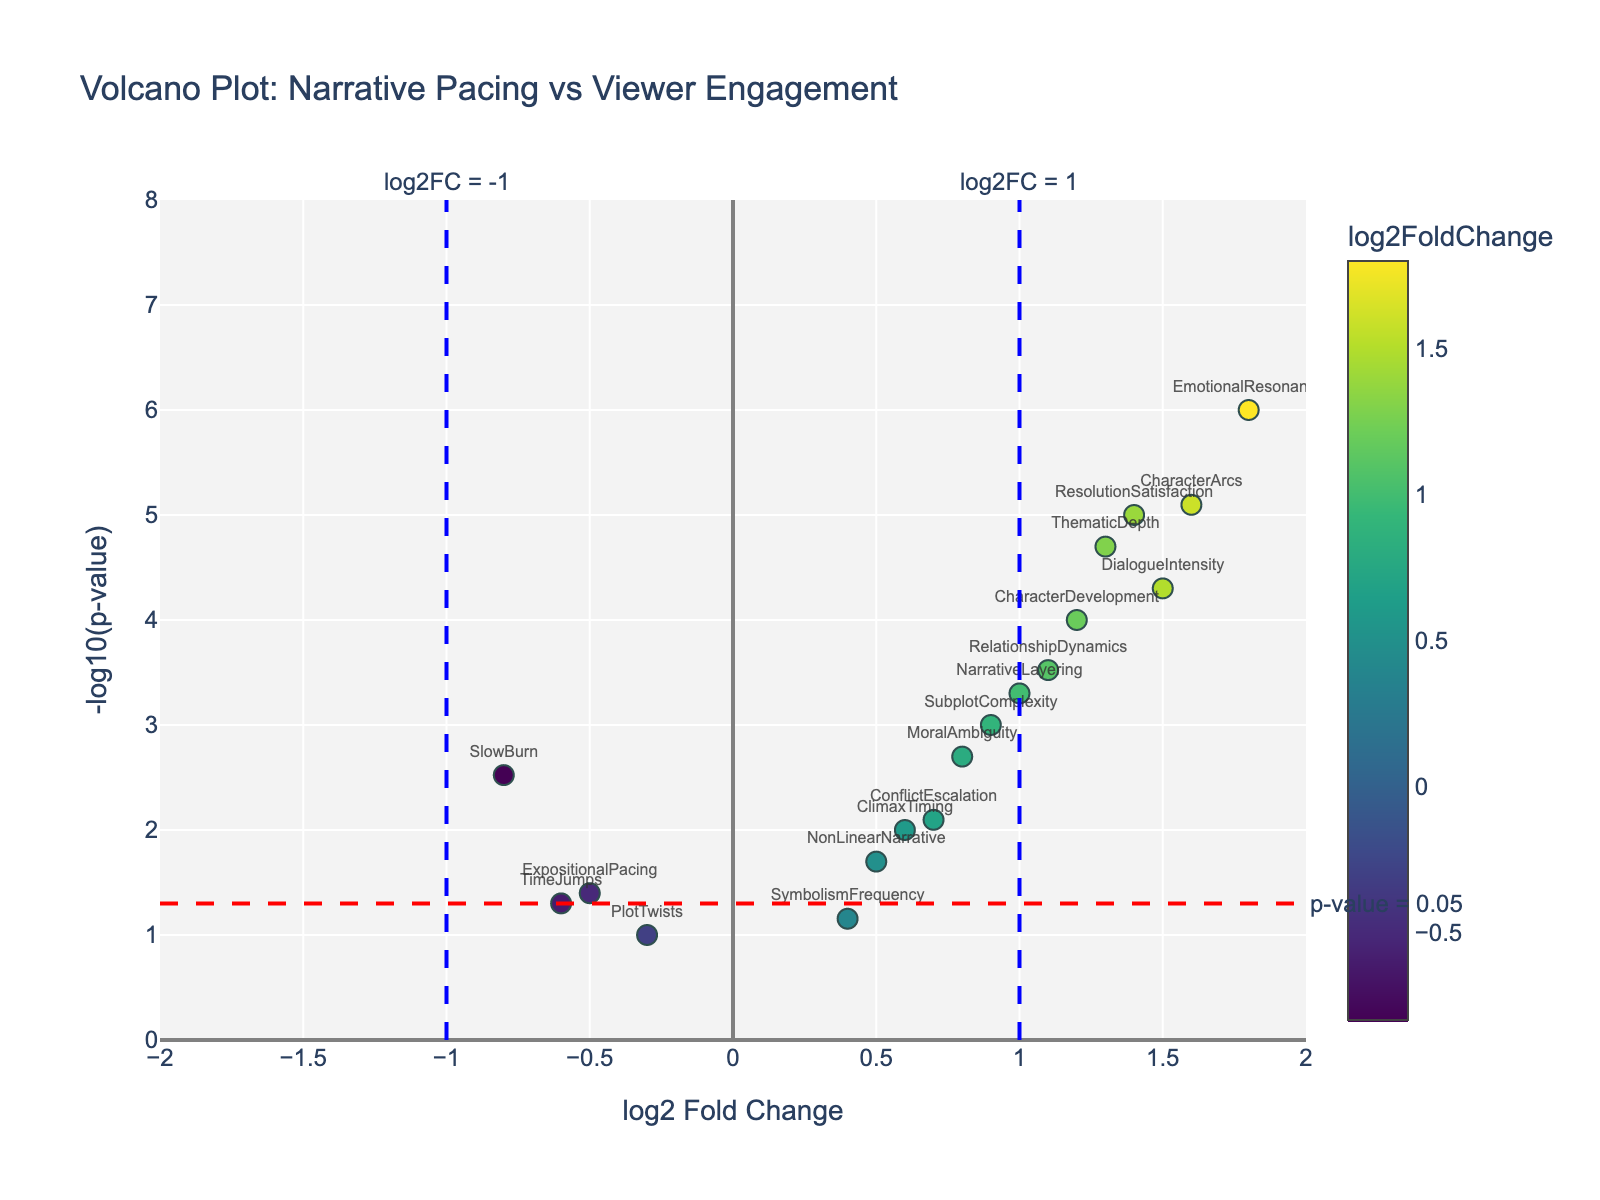What is the main title of the plot? The main title of the plot is the biggest text at the top. It reads "Volcano Plot: Narrative Pacing vs Viewer Engagement”.
Answer: "Volcano Plot: Narrative Pacing vs Viewer Engagement" What values are labeled on the x-axis in the plot? The x-axis of the plot is labeled with "log2 Fold Change," and the axis range appears to span from -2 to 2.
Answer: "log2 Fold Change" How many points are present in the plot? By counting the individual markers in the plot manually or by referring to the dataset, there are 18 points.
Answer: 18 What parameter does the color of the points represent? The color bar to the right of the plot shows that colors of the points represent the values of "log2FoldChange."
Answer: "log2FoldChange" What does the red horizontal line signify? The red horizontal line marks a threshold of p-value significance at 0.05, noted by the annotation "p-value = 0.05". Since the y-axis is -log10(p-value), the line is at y = 1.3.
Answer: p = 0.05 threshold Which data points display the highest log2FoldChange value? By looking at the plot, the point at the highest positive x-axis value for log2FoldChange represents "EmotionalResonance” with a log2FC of 1.8.
Answer: EmotionalResonance Which data point is closest to the blue vertical line at log2FC = 1? The point "ThematicDepth" is closest to the vertical line at log2FC = 1. The marker is visibly nearest to this threshold line.
Answer: ThematicDepth Among "PlotTwists" and "CharacterDevelopment," which has a more significant p-value? "PlotTwists" (p-value: 0.1) has a less significant p-value (higher) in comparison to "CharacterDevelopment" (p-value: 0.0001), which means "CharacterDevelopment" has a more significant p-value (lower).
Answer: CharacterDevelopment What data point exhibits the lowest p-value? The lowest p-value corresponds to the highest point on the y-axis, which is "EmotionalResonance" with -log10(p-value) = 6. That translates to a p-value of 1e-6.
Answer: EmotionalResonance What are the log2FoldChange and p-value of "DialogueIntensity"? From the hover text of the "DialogueIntensity" point, log2FC is 1.5 and p-value is 0.00005.
Answer: log2FC: 1.5, p-value: 0.00005 